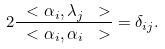<formula> <loc_0><loc_0><loc_500><loc_500>2 \frac { \ < \alpha _ { i } , \lambda _ { j } \ > } { \ < \alpha _ { i } , \alpha _ { i } \ > } = \delta _ { i j } .</formula> 